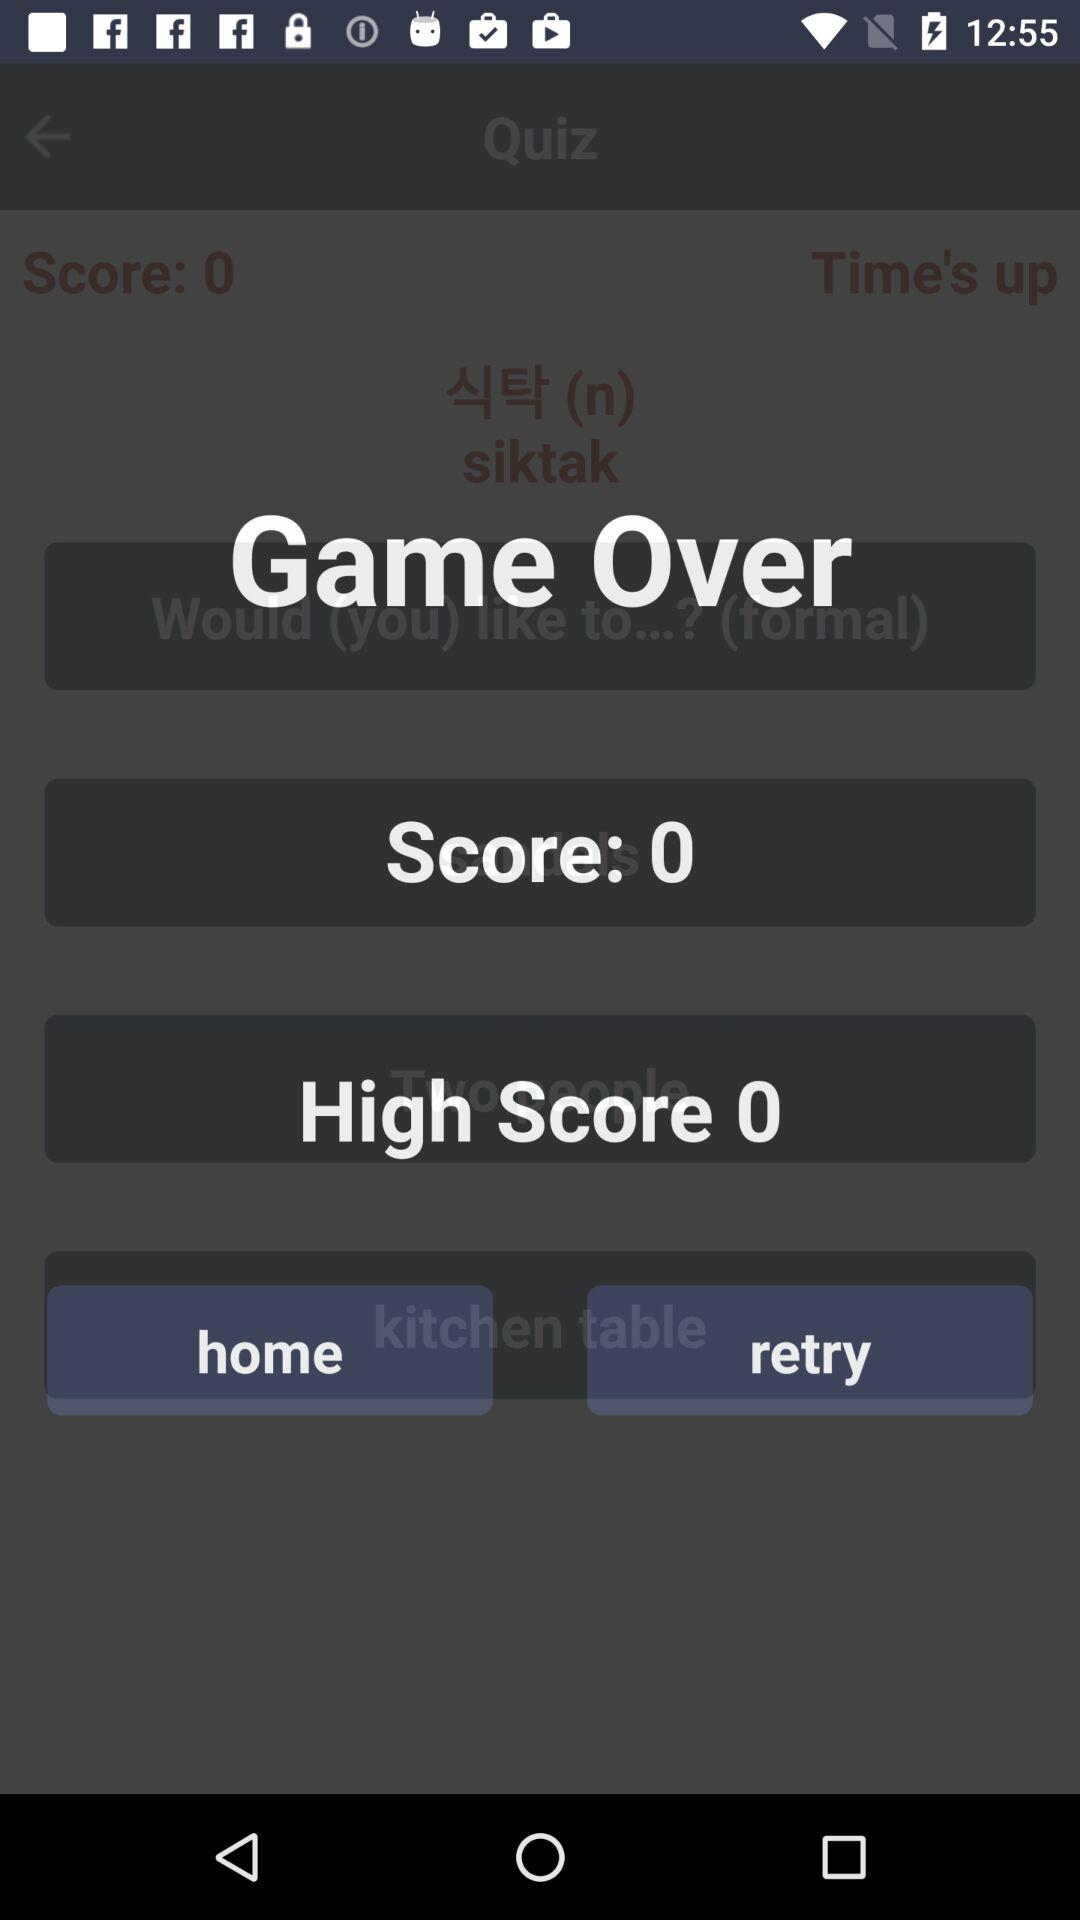What's the high score? The high score is 0. 